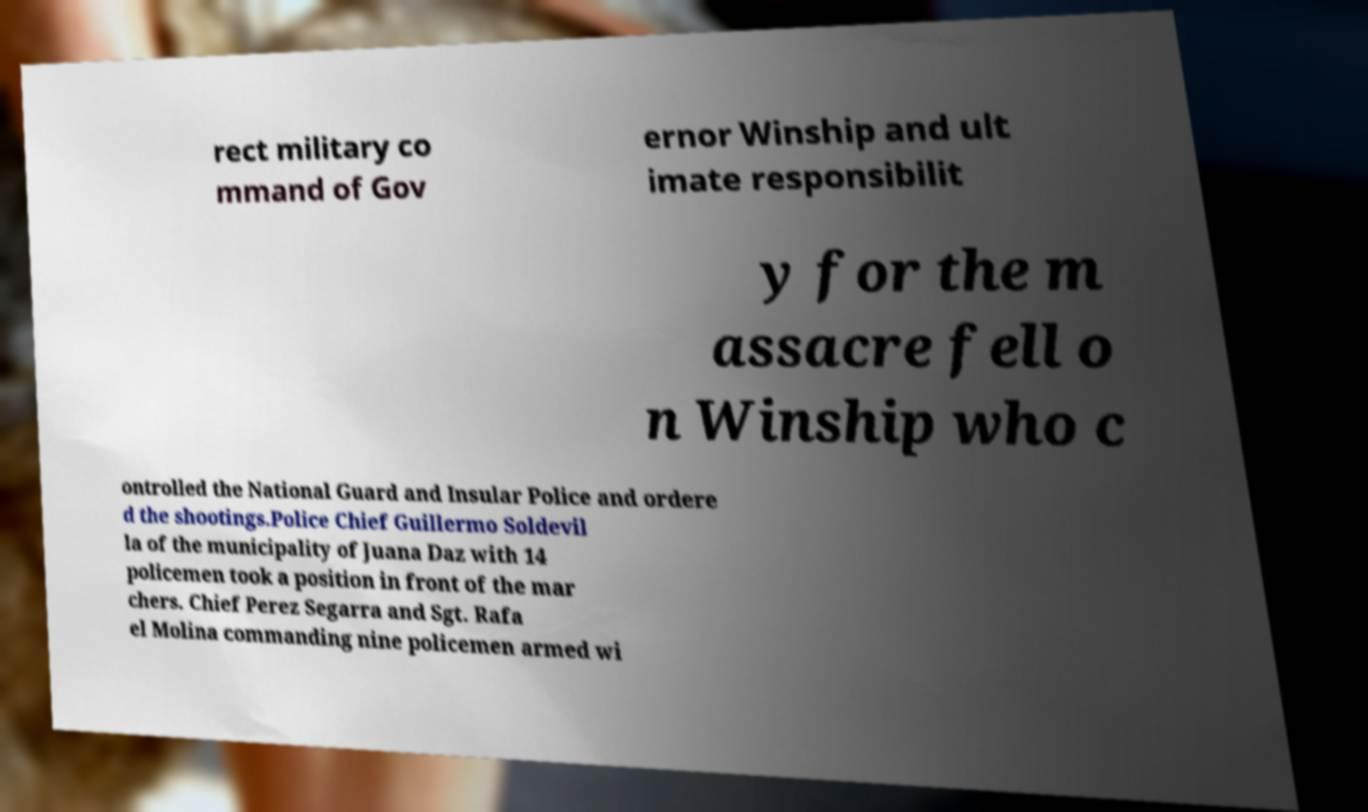There's text embedded in this image that I need extracted. Can you transcribe it verbatim? rect military co mmand of Gov ernor Winship and ult imate responsibilit y for the m assacre fell o n Winship who c ontrolled the National Guard and Insular Police and ordere d the shootings.Police Chief Guillermo Soldevil la of the municipality of Juana Daz with 14 policemen took a position in front of the mar chers. Chief Perez Segarra and Sgt. Rafa el Molina commanding nine policemen armed wi 